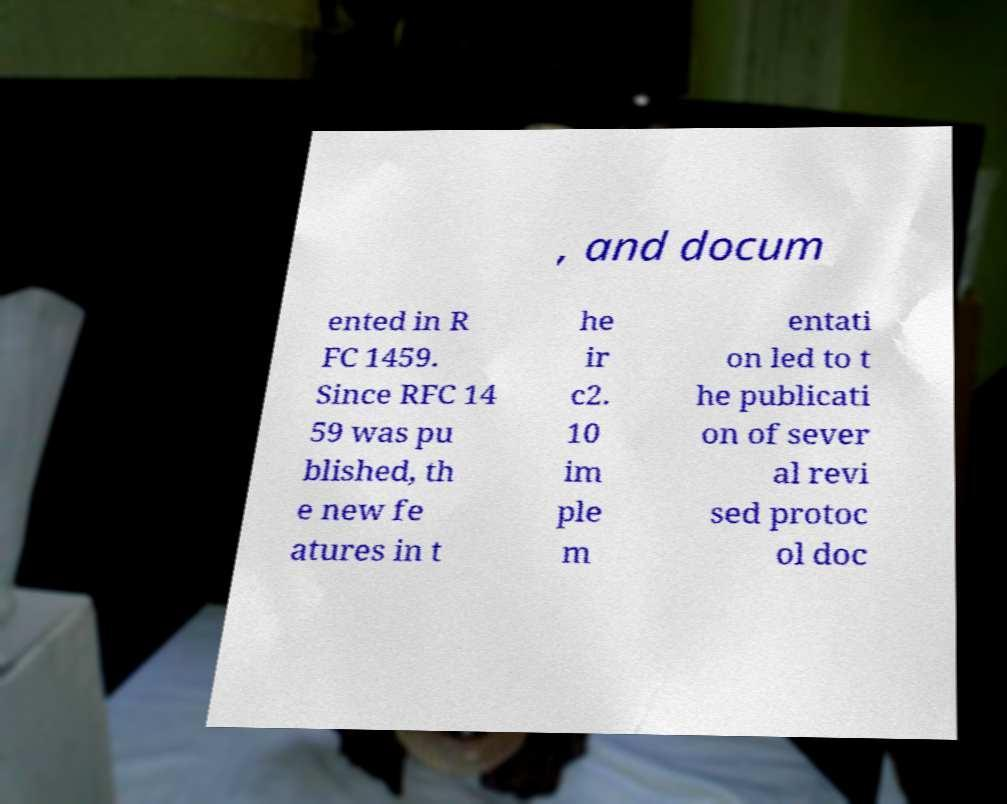Please identify and transcribe the text found in this image. , and docum ented in R FC 1459. Since RFC 14 59 was pu blished, th e new fe atures in t he ir c2. 10 im ple m entati on led to t he publicati on of sever al revi sed protoc ol doc 